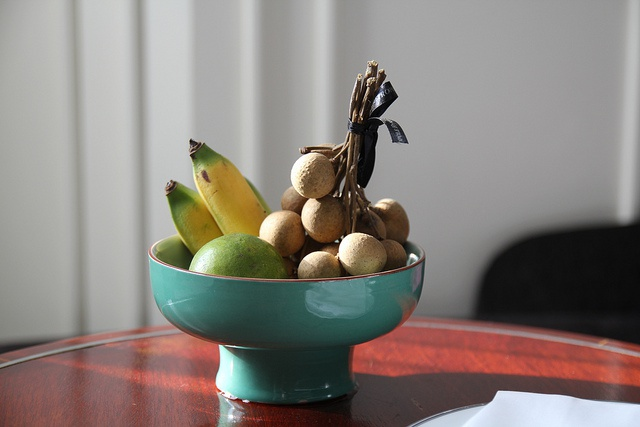Describe the objects in this image and their specific colors. I can see dining table in darkgray, brown, maroon, and salmon tones, bowl in darkgray, black, and teal tones, banana in darkgray and olive tones, and apple in darkgray, darkgreen, olive, and beige tones in this image. 